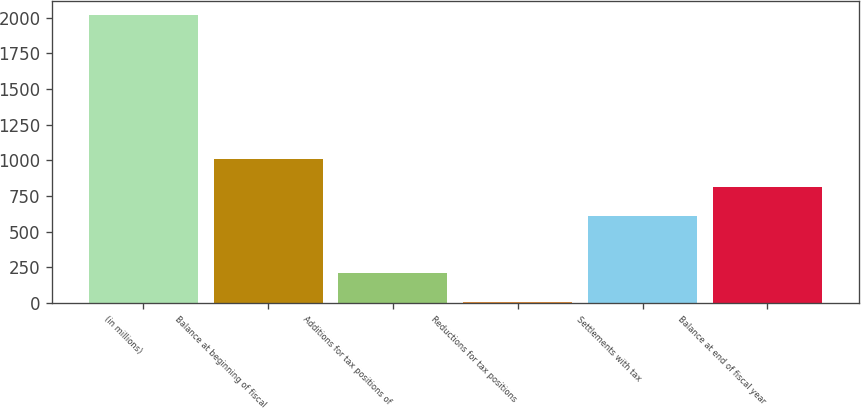Convert chart. <chart><loc_0><loc_0><loc_500><loc_500><bar_chart><fcel>(in millions)<fcel>Balance at beginning of fiscal<fcel>Additions for tax positions of<fcel>Reductions for tax positions<fcel>Settlements with tax<fcel>Balance at end of fiscal year<nl><fcel>2017<fcel>1012.5<fcel>208.9<fcel>8<fcel>610.7<fcel>811.6<nl></chart> 